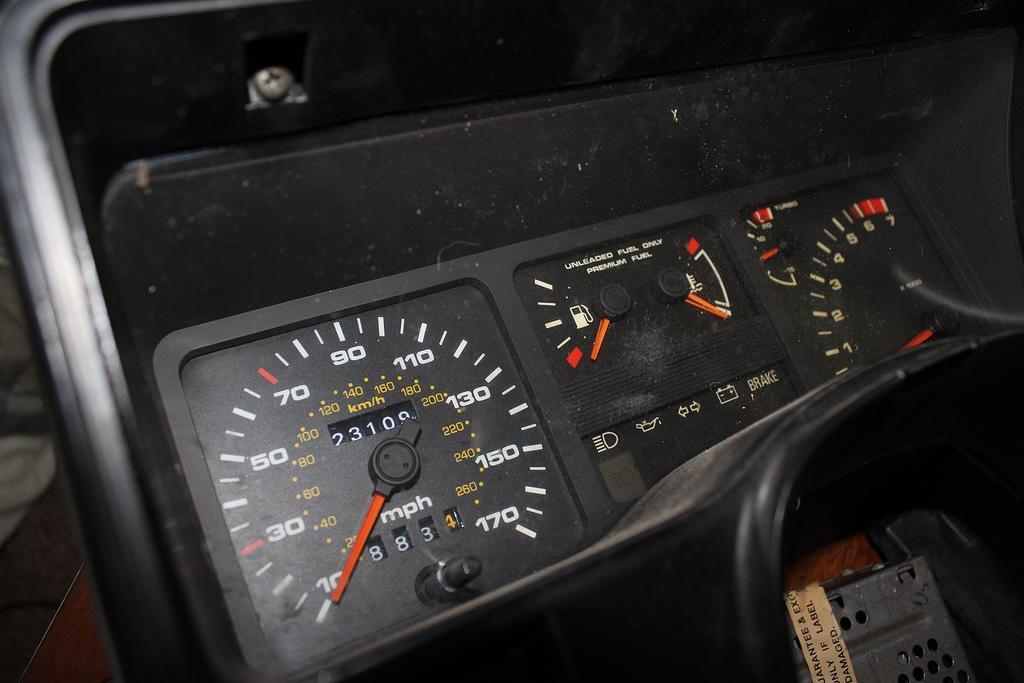Please provide a concise description of this image. In this image we can see a meter reading. 